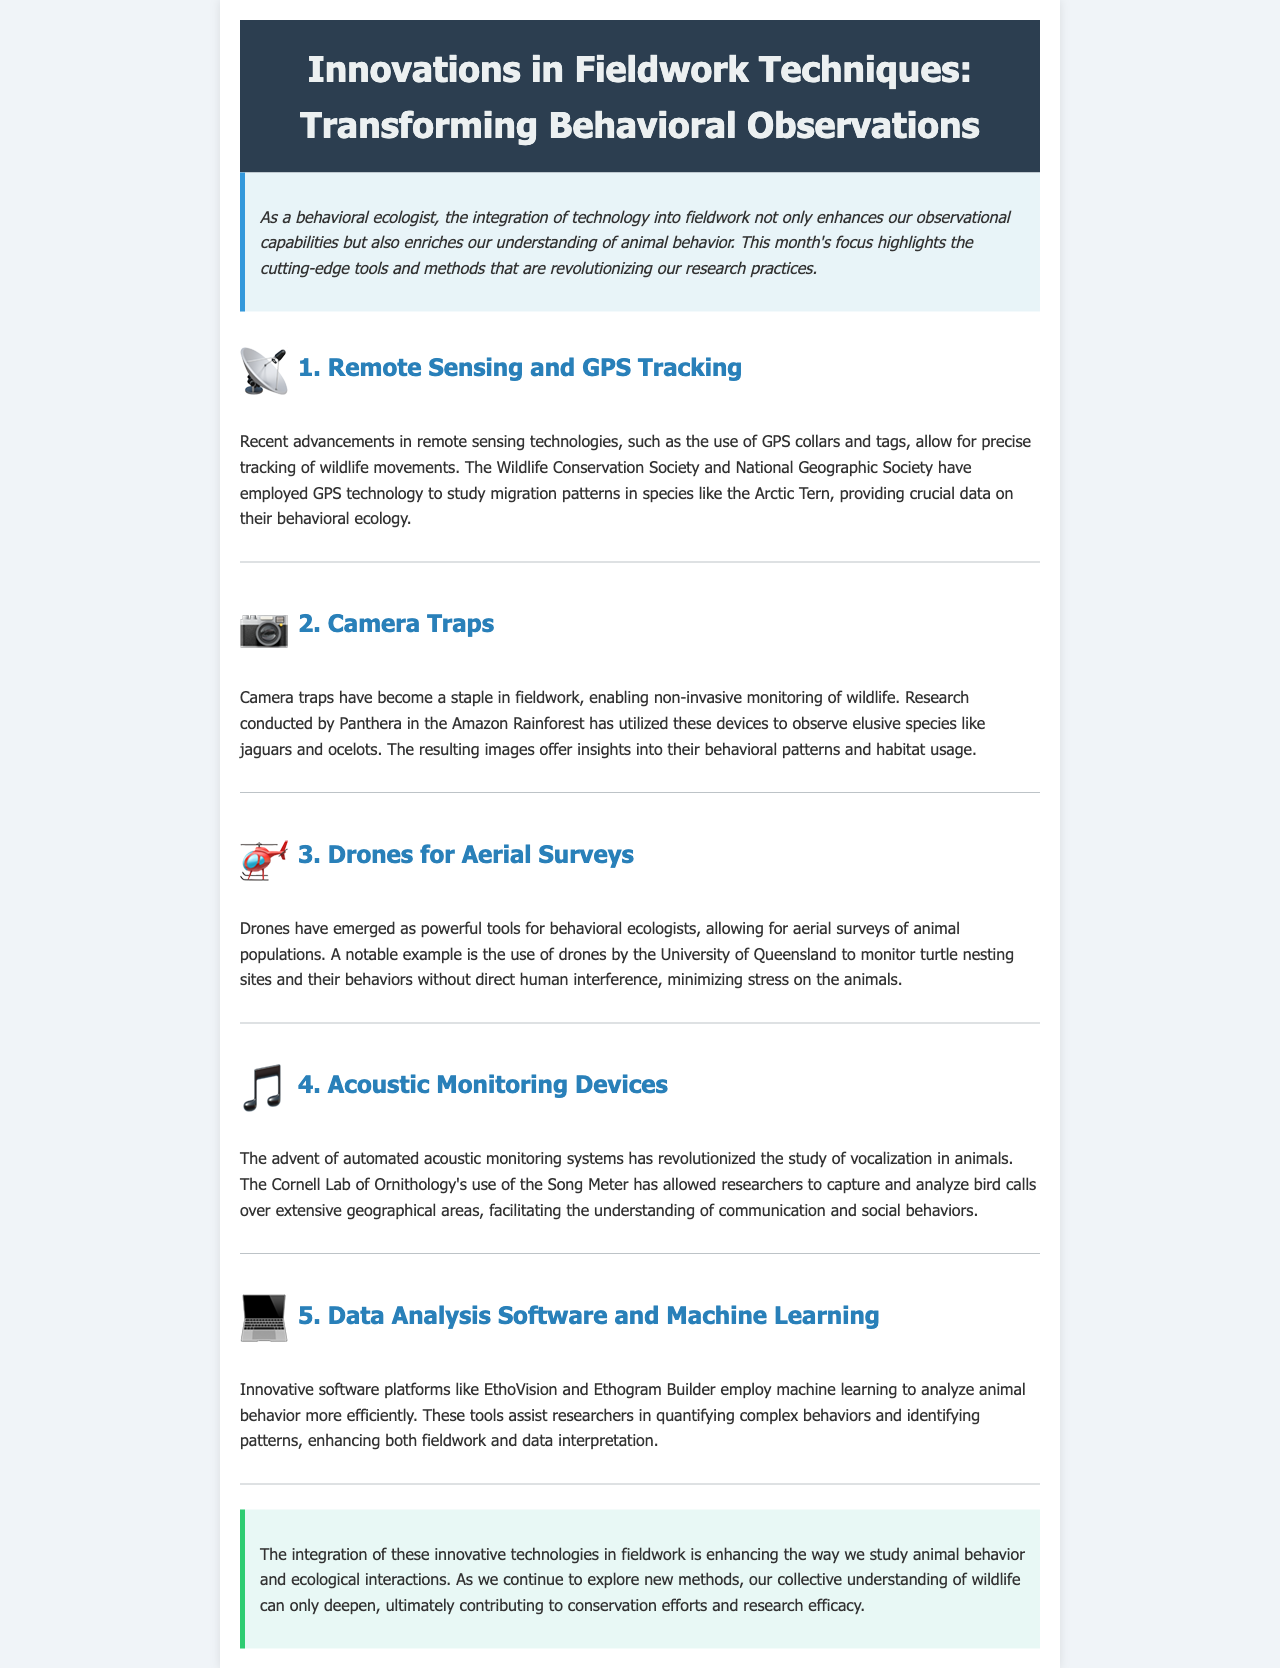What is the title of the newsletter? The title is prominently displayed in the header section of the document.
Answer: Innovations in Fieldwork Techniques: Transforming Behavioral Observations Who employs GPS technology to study migration patterns? The document mentions specific organizations using GPS technology for this purpose.
Answer: Wildlife Conservation Society and National Geographic Society What type of wildlife does Panthera observe using camera traps? The document specifies the elusive species being studied with camera traps.
Answer: Jaguars and ocelots Which university uses drones to monitor turtle nesting sites? The document provides the name of the institution utilizing drones for monitoring.
Answer: University of Queensland What device does the Cornell Lab of Ornithology use for acoustic monitoring? The document indicates the specific acoustic monitoring system used by this organization.
Answer: Song Meter How do innovative software platforms assist researchers? The document describes the function of software platforms in relation to animal behavior analysis.
Answer: Analyze animal behavior more efficiently What primary benefit do drones provide to behavioral ecologists? The document highlights the advantage of drones in ecological studies.
Answer: Minimize stress on the animals What theme does the conclusion emphasize regarding technological integration? The conclusion reflects on the overall impact of technology in wildlife research.
Answer: Enhancing the way we study animal behavior 